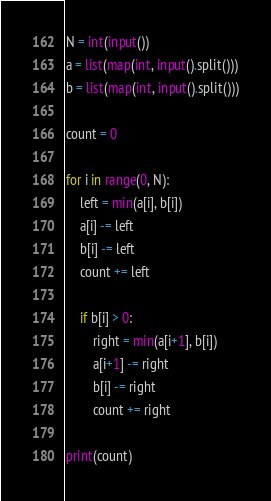Convert code to text. <code><loc_0><loc_0><loc_500><loc_500><_Python_>N = int(input())
a = list(map(int, input().split()))
b = list(map(int, input().split()))

count = 0

for i in range(0, N):
    left = min(a[i], b[i])
    a[i] -= left
    b[i] -= left
    count += left

    if b[i] > 0:
        right = min(a[i+1], b[i])
        a[i+1] -= right
        b[i] -= right
        count += right

print(count)</code> 